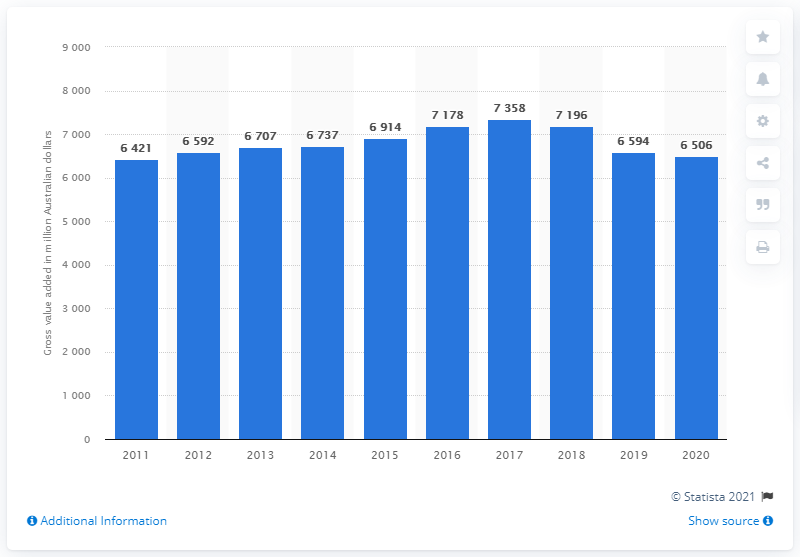Specify some key components in this picture. As of 2020, the forestry and fishing industry contributed a total of 6506 Australian dollars to the Australian economy. 